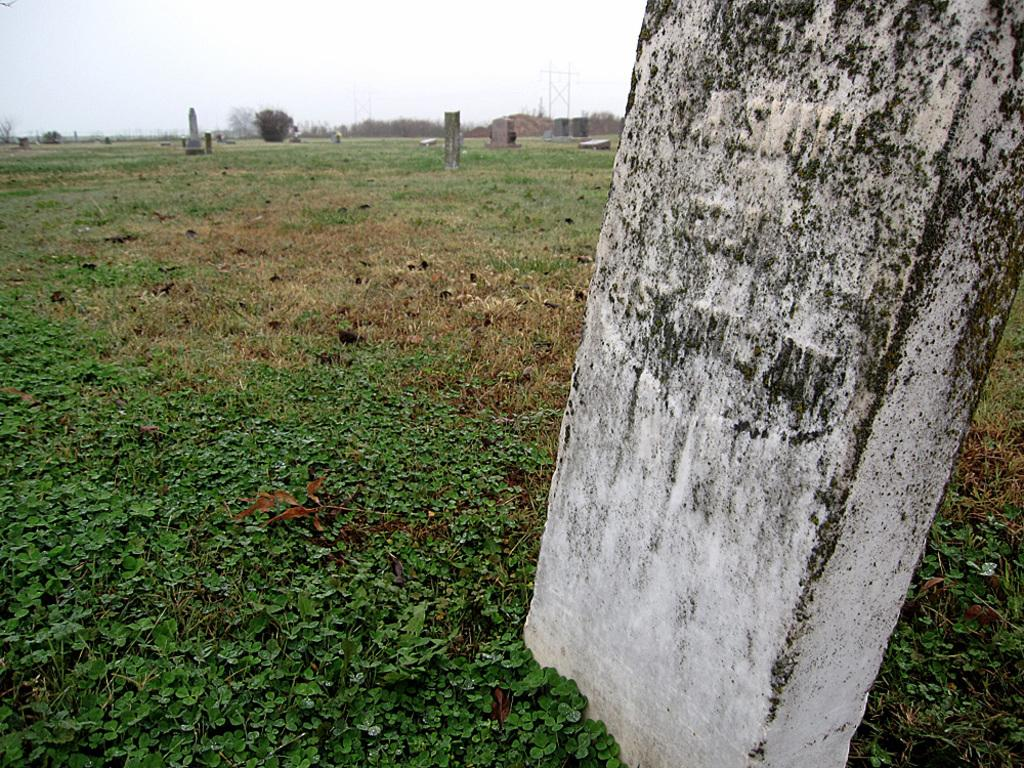What type of natural elements can be seen in the image? There are stones in the grass, as well as trees and plants in the image. What else can be seen in the image besides natural elements? There are poles in the image. What is visible in the background of the image? The sky is visible in the image. What type of face can be seen on the structure in the image? There is no structure with a face present in the image. 